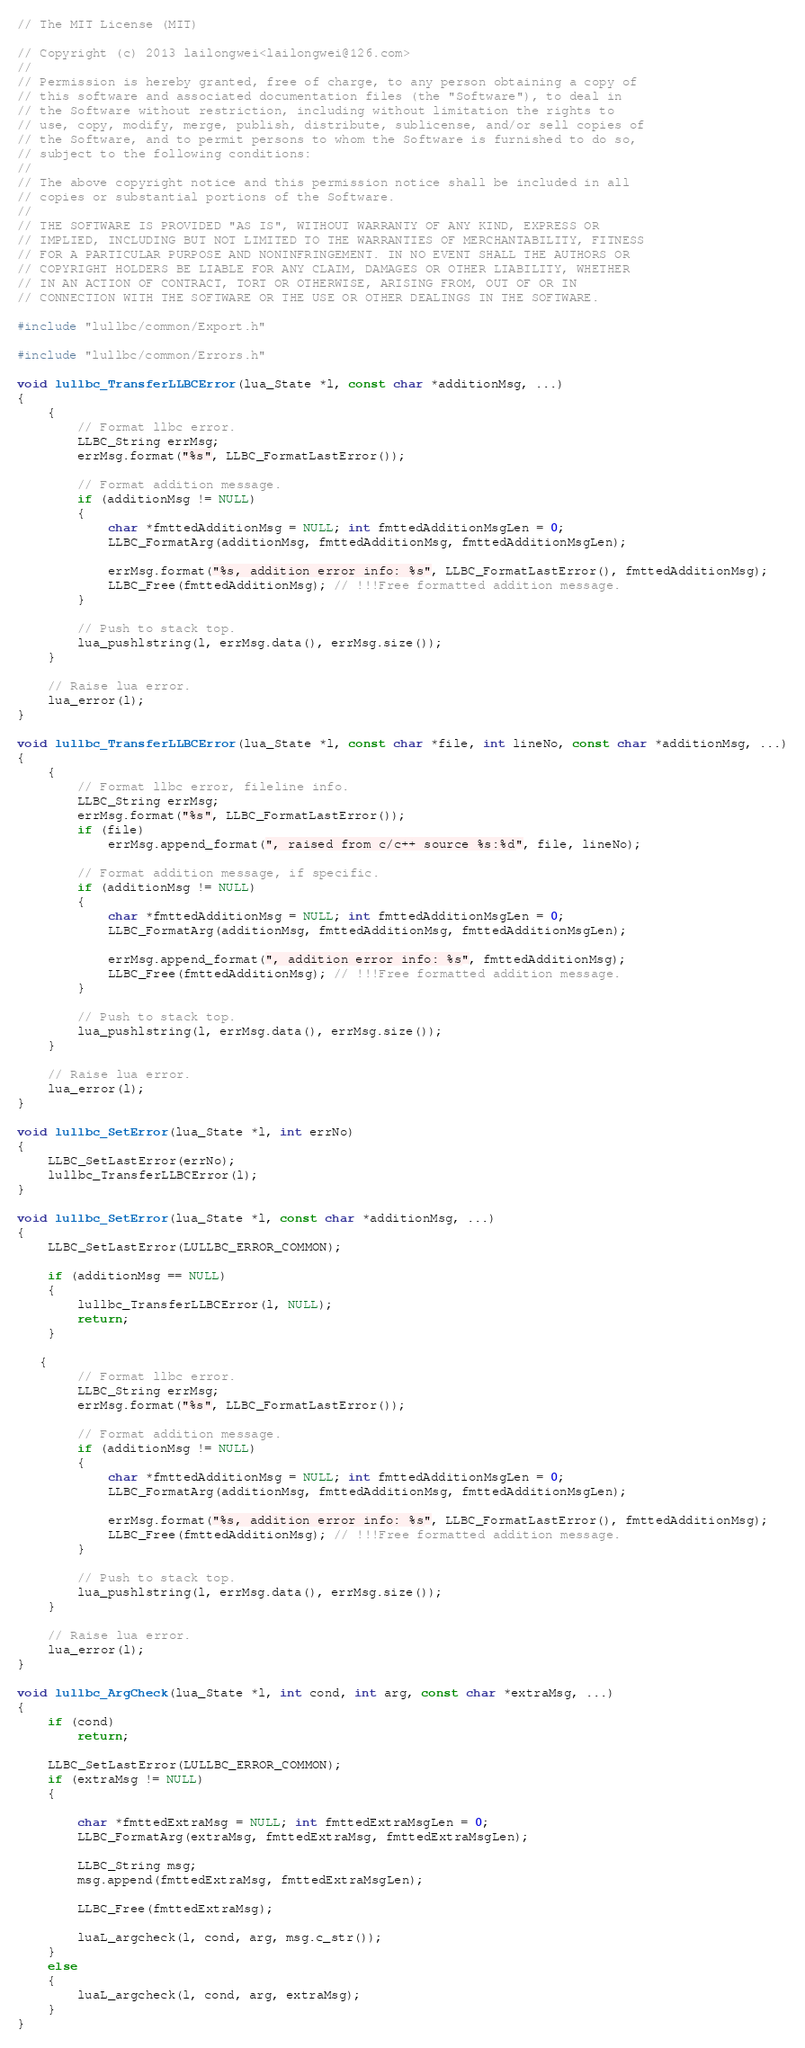<code> <loc_0><loc_0><loc_500><loc_500><_C++_>// The MIT License (MIT)

// Copyright (c) 2013 lailongwei<lailongwei@126.com>
// 
// Permission is hereby granted, free of charge, to any person obtaining a copy of 
// this software and associated documentation files (the "Software"), to deal in 
// the Software without restriction, including without limitation the rights to 
// use, copy, modify, merge, publish, distribute, sublicense, and/or sell copies of 
// the Software, and to permit persons to whom the Software is furnished to do so, 
// subject to the following conditions:
// 
// The above copyright notice and this permission notice shall be included in all 
// copies or substantial portions of the Software.
// 
// THE SOFTWARE IS PROVIDED "AS IS", WITHOUT WARRANTY OF ANY KIND, EXPRESS OR 
// IMPLIED, INCLUDING BUT NOT LIMITED TO THE WARRANTIES OF MERCHANTABILITY, FITNESS 
// FOR A PARTICULAR PURPOSE AND NONINFRINGEMENT. IN NO EVENT SHALL THE AUTHORS OR 
// COPYRIGHT HOLDERS BE LIABLE FOR ANY CLAIM, DAMAGES OR OTHER LIABILITY, WHETHER 
// IN AN ACTION OF CONTRACT, TORT OR OTHERWISE, ARISING FROM, OUT OF OR IN 
// CONNECTION WITH THE SOFTWARE OR THE USE OR OTHER DEALINGS IN THE SOFTWARE.

#include "lullbc/common/Export.h"

#include "lullbc/common/Errors.h"

void lullbc_TransferLLBCError(lua_State *l, const char *additionMsg, ...)
{
    {
        // Format llbc error.
        LLBC_String errMsg;
        errMsg.format("%s", LLBC_FormatLastError());

        // Format addition message.
        if (additionMsg != NULL)
        {
            char *fmttedAdditionMsg = NULL; int fmttedAdditionMsgLen = 0;
            LLBC_FormatArg(additionMsg, fmttedAdditionMsg, fmttedAdditionMsgLen);

            errMsg.format("%s, addition error info: %s", LLBC_FormatLastError(), fmttedAdditionMsg);
            LLBC_Free(fmttedAdditionMsg); // !!!Free formatted addition message.
        }

        // Push to stack top.
        lua_pushlstring(l, errMsg.data(), errMsg.size());
    }

    // Raise lua error.
    lua_error(l);
}

void lullbc_TransferLLBCError(lua_State *l, const char *file, int lineNo, const char *additionMsg, ...)
{
    {
        // Format llbc error, fileline info.
        LLBC_String errMsg;
        errMsg.format("%s", LLBC_FormatLastError());
        if (file)
            errMsg.append_format(", raised from c/c++ source %s:%d", file, lineNo);

        // Format addition message, if specific.
        if (additionMsg != NULL)
        {
            char *fmttedAdditionMsg = NULL; int fmttedAdditionMsgLen = 0;
            LLBC_FormatArg(additionMsg, fmttedAdditionMsg, fmttedAdditionMsgLen);

            errMsg.append_format(", addition error info: %s", fmttedAdditionMsg);
            LLBC_Free(fmttedAdditionMsg); // !!!Free formatted addition message.
        }
        
        // Push to stack top.
        lua_pushlstring(l, errMsg.data(), errMsg.size());
    }

    // Raise lua error.
    lua_error(l);
}

void lullbc_SetError(lua_State *l, int errNo)
{
    LLBC_SetLastError(errNo);
    lullbc_TransferLLBCError(l);
}

void lullbc_SetError(lua_State *l, const char *additionMsg, ...)
{
    LLBC_SetLastError(LULLBC_ERROR_COMMON);

    if (additionMsg == NULL)
    {
        lullbc_TransferLLBCError(l, NULL);
        return;
    }
 
   {
        // Format llbc error.
        LLBC_String errMsg;
        errMsg.format("%s", LLBC_FormatLastError());

        // Format addition message.
        if (additionMsg != NULL)
        {
            char *fmttedAdditionMsg = NULL; int fmttedAdditionMsgLen = 0;
            LLBC_FormatArg(additionMsg, fmttedAdditionMsg, fmttedAdditionMsgLen);

            errMsg.format("%s, addition error info: %s", LLBC_FormatLastError(), fmttedAdditionMsg);
            LLBC_Free(fmttedAdditionMsg); // !!!Free formatted addition message.
        }

        // Push to stack top.
        lua_pushlstring(l, errMsg.data(), errMsg.size());
    }

    // Raise lua error.
    lua_error(l);
}

void lullbc_ArgCheck(lua_State *l, int cond, int arg, const char *extraMsg, ...)
{
    if (cond)
        return;

    LLBC_SetLastError(LULLBC_ERROR_COMMON);
    if (extraMsg != NULL)
    {

        char *fmttedExtraMsg = NULL; int fmttedExtraMsgLen = 0;
        LLBC_FormatArg(extraMsg, fmttedExtraMsg, fmttedExtraMsgLen);

        LLBC_String msg;
        msg.append(fmttedExtraMsg, fmttedExtraMsgLen);

        LLBC_Free(fmttedExtraMsg);

        luaL_argcheck(l, cond, arg, msg.c_str());
    }
    else
    {
        luaL_argcheck(l, cond, arg, extraMsg);
    }
}</code> 